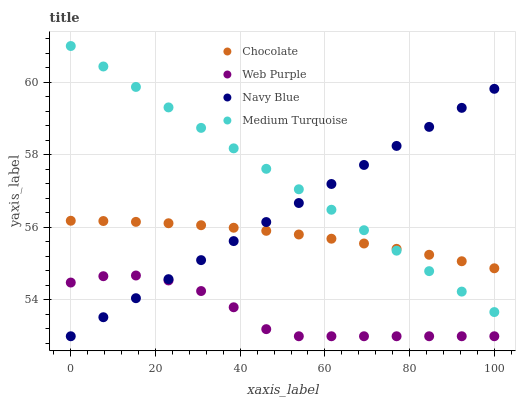Does Web Purple have the minimum area under the curve?
Answer yes or no. Yes. Does Medium Turquoise have the maximum area under the curve?
Answer yes or no. Yes. Does Medium Turquoise have the minimum area under the curve?
Answer yes or no. No. Does Web Purple have the maximum area under the curve?
Answer yes or no. No. Is Medium Turquoise the smoothest?
Answer yes or no. Yes. Is Web Purple the roughest?
Answer yes or no. Yes. Is Web Purple the smoothest?
Answer yes or no. No. Is Medium Turquoise the roughest?
Answer yes or no. No. Does Navy Blue have the lowest value?
Answer yes or no. Yes. Does Medium Turquoise have the lowest value?
Answer yes or no. No. Does Medium Turquoise have the highest value?
Answer yes or no. Yes. Does Web Purple have the highest value?
Answer yes or no. No. Is Web Purple less than Medium Turquoise?
Answer yes or no. Yes. Is Medium Turquoise greater than Web Purple?
Answer yes or no. Yes. Does Navy Blue intersect Web Purple?
Answer yes or no. Yes. Is Navy Blue less than Web Purple?
Answer yes or no. No. Is Navy Blue greater than Web Purple?
Answer yes or no. No. Does Web Purple intersect Medium Turquoise?
Answer yes or no. No. 